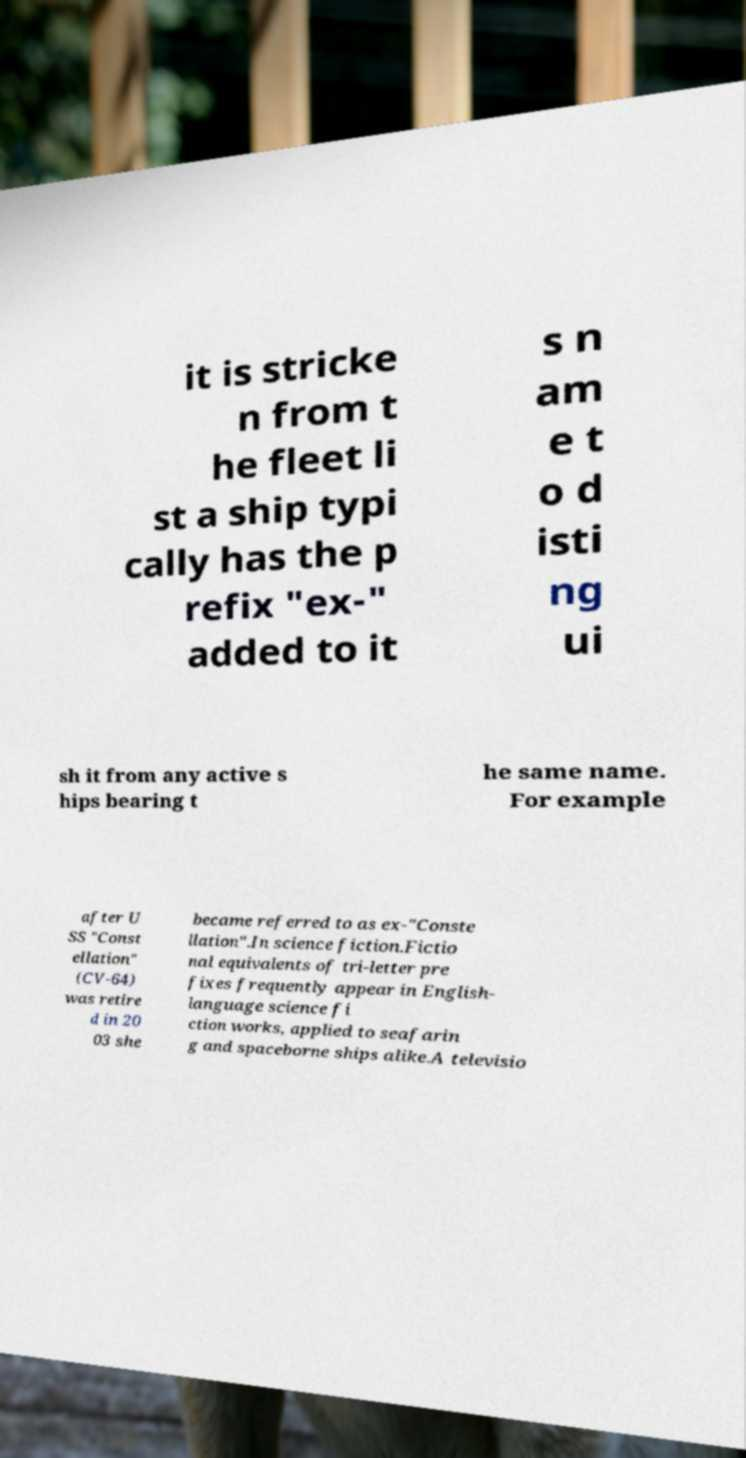Could you assist in decoding the text presented in this image and type it out clearly? it is stricke n from t he fleet li st a ship typi cally has the p refix "ex-" added to it s n am e t o d isti ng ui sh it from any active s hips bearing t he same name. For example after U SS "Const ellation" (CV-64) was retire d in 20 03 she became referred to as ex-"Conste llation".In science fiction.Fictio nal equivalents of tri-letter pre fixes frequently appear in English- language science fi ction works, applied to seafarin g and spaceborne ships alike.A televisio 